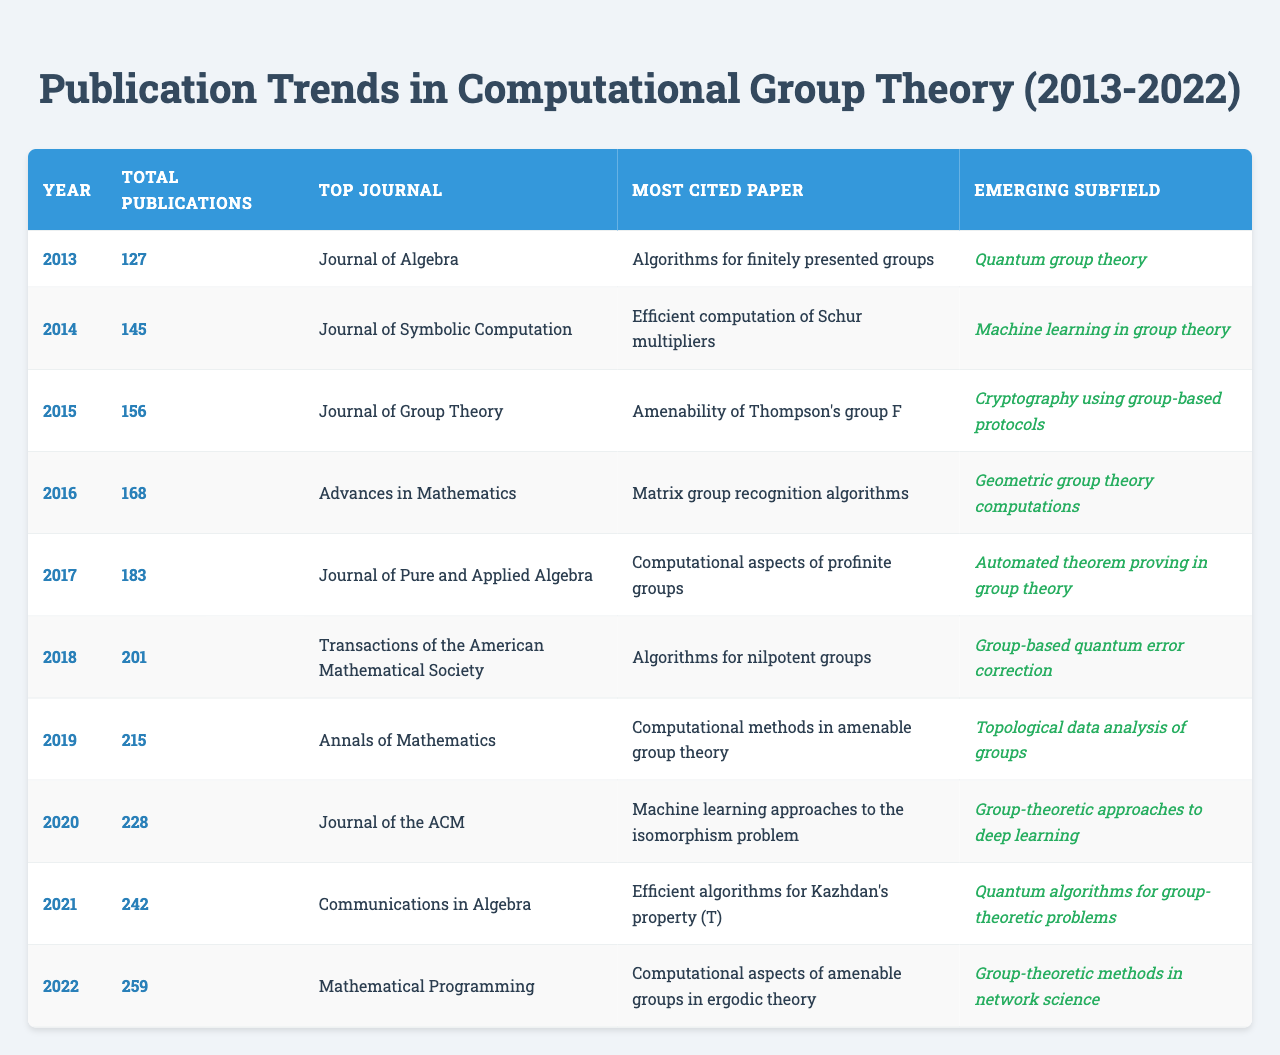What was the total number of publications in 2019? In the table, under the "Total Publications" column for the year 2019, the value is 215.
Answer: 215 Which journal had the most publications in 2022? Referring to the "Top Journal" column for the year 2022, the journal listed is "Mathematical Programming."
Answer: Mathematical Programming What is the average number of publications from 2013 to 2022? The total number of publications from 2013 to 2022 can be calculated by summing all publications (127 + 145 + 156 + 168 + 183 + 201 + 215 + 228 + 242 + 259 = 1,810). There are 10 data points (years), thus the average is 1,810 / 10 = 181.
Answer: 181 In what year did the top journal change from "Journal of Algebra" to "Journal of Symbolic Computation"? The change occurs between 2013 (Journal of Algebra) and 2014 (Journal of Symbolic Computation). Hence, the transition happens in 2014.
Answer: 2014 How did the number of publications in 2020 compare to 2018? In 2020, there were 228 publications and in 2018, there were 201 publications. To find the difference: 228 - 201 = 27. Therefore, there were 27 more publications in 2020 than in 2018.
Answer: 27 Was there an increasing trend in total publications from 2013 to 2022? Yes, the total publications increased every year from 2013 (127) to 2022 (259). This indicates a consistent upward trend.
Answer: Yes Which year had the highest total publications, and how many were there? The year with the highest total publications is 2022, with 259 publications. This can be verified by checking the "Total Publications" column for each year.
Answer: 2022, 259 What are the different emerging subfields listed from 2013 to 2022? The emerging subfields for each year from 2013 to 2022 can be extracted from the corresponding column: Quantum group theory, Machine learning in group theory, Cryptography using group-based protocols, Geometric group theory computations, Automated theorem proving in group theory, Group-based quantum error correction, Topological data analysis of groups, Group-theoretic approaches to deep learning, Quantum algorithms for group-theoretic problems, Group-theoretic methods in network science.
Answer: 10 Which paper was the most cited in 2015? The most cited paper in 2015 is "Amenability of Thompson's group F," as indicated in the "Most Cited Paper" column for that year.
Answer: Amenability of Thompson's group F What was the trend in emerging subfields over the years from 2013 to 2022? Across the years, the emerging subfields evolved from foundational concepts like Quantum group theory and machine learning applications, signifying a diversification and specialization in the computational group theory domain as indicated by the varying subfields listed per year.
Answer: Diversification and specialization 